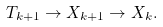<formula> <loc_0><loc_0><loc_500><loc_500>T _ { k + 1 } \to X _ { k + 1 } \to X _ { k } .</formula> 